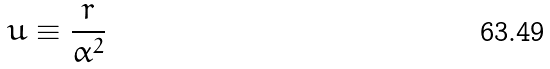<formula> <loc_0><loc_0><loc_500><loc_500>u \equiv \frac { r } { \alpha ^ { 2 } }</formula> 